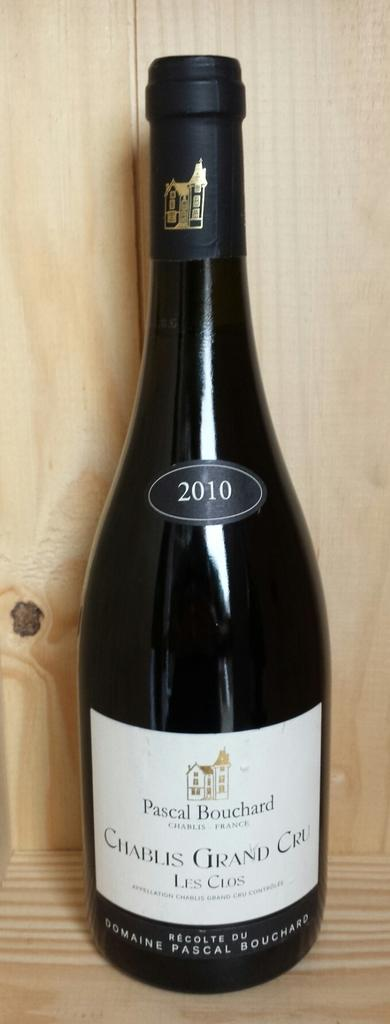Provide a one-sentence caption for the provided image. A dark bottle of Cablis Grand Cru, 2010 sitting on a wood platform. 